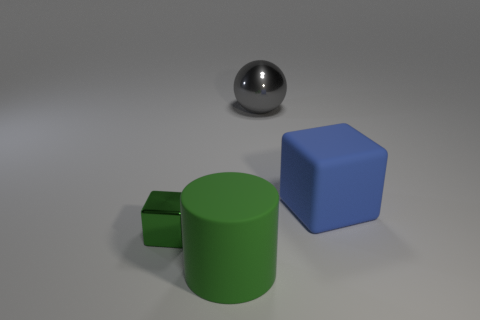Is the size of the green block that is to the left of the gray metal sphere the same as the object right of the ball?
Ensure brevity in your answer.  No. What number of things are big matte objects that are behind the green metallic object or purple rubber cubes?
Offer a terse response. 1. What material is the cube that is right of the big gray sphere?
Ensure brevity in your answer.  Rubber. What is the material of the tiny object?
Keep it short and to the point. Metal. There is a cube that is on the right side of the thing to the left of the large thing on the left side of the gray metal object; what is its material?
Your response must be concise. Rubber. Is there anything else that is the same material as the large green thing?
Make the answer very short. Yes. Is the size of the blue rubber object the same as the metallic thing on the left side of the large gray thing?
Offer a very short reply. No. What number of objects are objects in front of the large blue rubber object or rubber objects that are on the right side of the gray thing?
Your answer should be compact. 3. The thing to the right of the metal sphere is what color?
Offer a terse response. Blue. Are there any big cylinders that are behind the big object to the left of the metal ball?
Offer a terse response. No. 